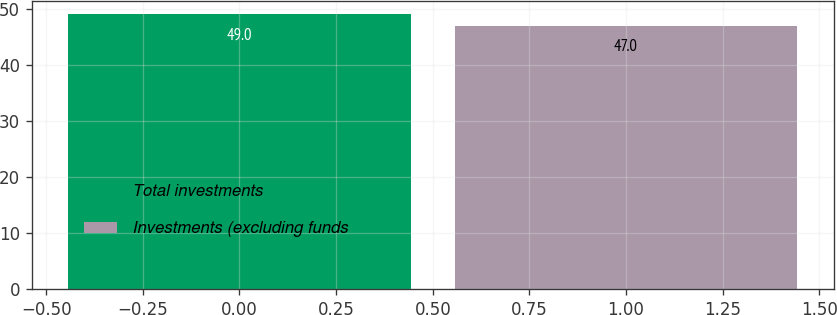Convert chart to OTSL. <chart><loc_0><loc_0><loc_500><loc_500><bar_chart><fcel>Total investments<fcel>Investments (excluding funds<nl><fcel>49<fcel>47<nl></chart> 